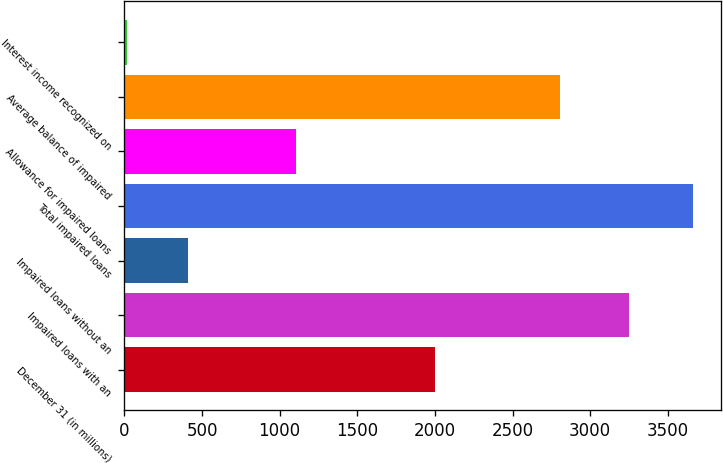Convert chart. <chart><loc_0><loc_0><loc_500><loc_500><bar_chart><fcel>December 31 (in millions)<fcel>Impaired loans with an<fcel>Impaired loans without an<fcel>Total impaired loans<fcel>Allowance for impaired loans<fcel>Average balance of impaired<fcel>Interest income recognized on<nl><fcel>2002<fcel>3250<fcel>412<fcel>3662<fcel>1106<fcel>2805<fcel>14<nl></chart> 